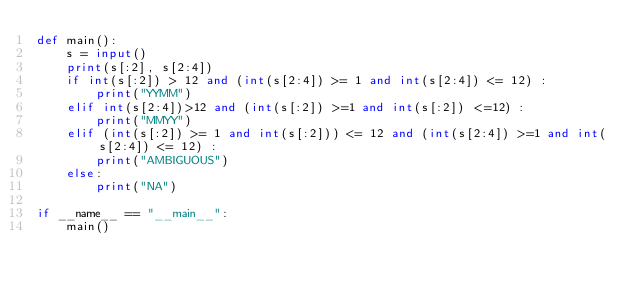Convert code to text. <code><loc_0><loc_0><loc_500><loc_500><_Python_>def main():
    s = input()
    print(s[:2], s[2:4])
    if int(s[:2]) > 12 and (int(s[2:4]) >= 1 and int(s[2:4]) <= 12) :
        print("YYMM")
    elif int(s[2:4])>12 and (int(s[:2]) >=1 and int(s[:2]) <=12) :
        print("MMYY")
    elif (int(s[:2]) >= 1 and int(s[:2])) <= 12 and (int(s[2:4]) >=1 and int(s[2:4]) <= 12) :
        print("AMBIGUOUS")
    else:
        print("NA")

if __name__ == "__main__":
    main()
</code> 